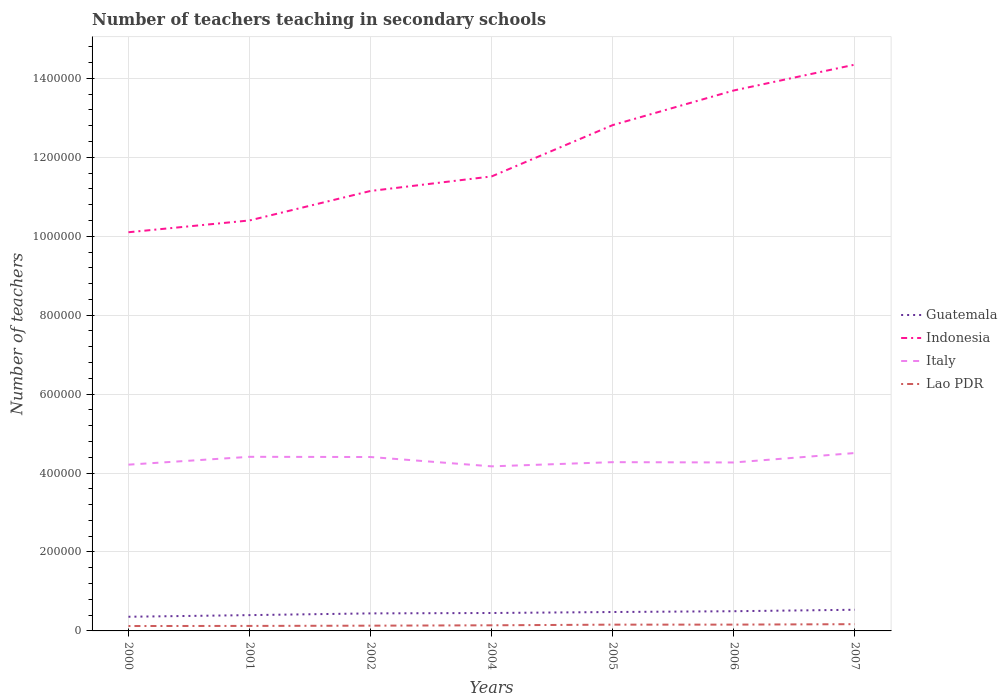How many different coloured lines are there?
Your answer should be compact. 4. Does the line corresponding to Italy intersect with the line corresponding to Indonesia?
Provide a short and direct response. No. Across all years, what is the maximum number of teachers teaching in secondary schools in Indonesia?
Your answer should be very brief. 1.01e+06. In which year was the number of teachers teaching in secondary schools in Italy maximum?
Keep it short and to the point. 2004. What is the total number of teachers teaching in secondary schools in Guatemala in the graph?
Your answer should be very brief. -2504. What is the difference between the highest and the second highest number of teachers teaching in secondary schools in Italy?
Your answer should be compact. 3.37e+04. What is the difference between the highest and the lowest number of teachers teaching in secondary schools in Italy?
Your answer should be very brief. 3. Does the graph contain any zero values?
Provide a succinct answer. No. How are the legend labels stacked?
Provide a short and direct response. Vertical. What is the title of the graph?
Offer a terse response. Number of teachers teaching in secondary schools. Does "Sint Maarten (Dutch part)" appear as one of the legend labels in the graph?
Your answer should be compact. No. What is the label or title of the X-axis?
Offer a very short reply. Years. What is the label or title of the Y-axis?
Keep it short and to the point. Number of teachers. What is the Number of teachers of Guatemala in 2000?
Your answer should be compact. 3.59e+04. What is the Number of teachers in Indonesia in 2000?
Give a very brief answer. 1.01e+06. What is the Number of teachers of Italy in 2000?
Make the answer very short. 4.21e+05. What is the Number of teachers of Lao PDR in 2000?
Keep it short and to the point. 1.24e+04. What is the Number of teachers of Guatemala in 2001?
Keep it short and to the point. 4.00e+04. What is the Number of teachers of Indonesia in 2001?
Ensure brevity in your answer.  1.04e+06. What is the Number of teachers in Italy in 2001?
Offer a very short reply. 4.41e+05. What is the Number of teachers of Lao PDR in 2001?
Give a very brief answer. 1.27e+04. What is the Number of teachers in Guatemala in 2002?
Provide a short and direct response. 4.44e+04. What is the Number of teachers of Indonesia in 2002?
Ensure brevity in your answer.  1.11e+06. What is the Number of teachers of Italy in 2002?
Offer a terse response. 4.41e+05. What is the Number of teachers in Lao PDR in 2002?
Ensure brevity in your answer.  1.33e+04. What is the Number of teachers of Guatemala in 2004?
Make the answer very short. 4.54e+04. What is the Number of teachers of Indonesia in 2004?
Offer a terse response. 1.15e+06. What is the Number of teachers of Italy in 2004?
Make the answer very short. 4.17e+05. What is the Number of teachers of Lao PDR in 2004?
Provide a succinct answer. 1.43e+04. What is the Number of teachers in Guatemala in 2005?
Provide a short and direct response. 4.79e+04. What is the Number of teachers in Indonesia in 2005?
Provide a succinct answer. 1.28e+06. What is the Number of teachers in Italy in 2005?
Provide a succinct answer. 4.28e+05. What is the Number of teachers of Lao PDR in 2005?
Offer a terse response. 1.59e+04. What is the Number of teachers in Guatemala in 2006?
Your response must be concise. 4.99e+04. What is the Number of teachers of Indonesia in 2006?
Provide a short and direct response. 1.37e+06. What is the Number of teachers in Italy in 2006?
Provide a short and direct response. 4.27e+05. What is the Number of teachers in Lao PDR in 2006?
Your response must be concise. 1.60e+04. What is the Number of teachers of Guatemala in 2007?
Your response must be concise. 5.36e+04. What is the Number of teachers of Indonesia in 2007?
Your answer should be compact. 1.43e+06. What is the Number of teachers in Italy in 2007?
Provide a short and direct response. 4.51e+05. What is the Number of teachers of Lao PDR in 2007?
Provide a succinct answer. 1.71e+04. Across all years, what is the maximum Number of teachers in Guatemala?
Your answer should be very brief. 5.36e+04. Across all years, what is the maximum Number of teachers in Indonesia?
Provide a short and direct response. 1.43e+06. Across all years, what is the maximum Number of teachers in Italy?
Give a very brief answer. 4.51e+05. Across all years, what is the maximum Number of teachers in Lao PDR?
Your answer should be very brief. 1.71e+04. Across all years, what is the minimum Number of teachers of Guatemala?
Ensure brevity in your answer.  3.59e+04. Across all years, what is the minimum Number of teachers in Indonesia?
Your answer should be very brief. 1.01e+06. Across all years, what is the minimum Number of teachers in Italy?
Your answer should be compact. 4.17e+05. Across all years, what is the minimum Number of teachers of Lao PDR?
Your answer should be compact. 1.24e+04. What is the total Number of teachers in Guatemala in the graph?
Offer a very short reply. 3.17e+05. What is the total Number of teachers in Indonesia in the graph?
Offer a terse response. 8.40e+06. What is the total Number of teachers in Italy in the graph?
Provide a succinct answer. 3.03e+06. What is the total Number of teachers in Lao PDR in the graph?
Keep it short and to the point. 1.02e+05. What is the difference between the Number of teachers in Guatemala in 2000 and that in 2001?
Offer a very short reply. -4119. What is the difference between the Number of teachers of Indonesia in 2000 and that in 2001?
Your answer should be compact. -2.99e+04. What is the difference between the Number of teachers in Italy in 2000 and that in 2001?
Your answer should be compact. -1.99e+04. What is the difference between the Number of teachers in Lao PDR in 2000 and that in 2001?
Your answer should be compact. -284. What is the difference between the Number of teachers in Guatemala in 2000 and that in 2002?
Your response must be concise. -8525. What is the difference between the Number of teachers in Indonesia in 2000 and that in 2002?
Give a very brief answer. -1.05e+05. What is the difference between the Number of teachers of Italy in 2000 and that in 2002?
Provide a succinct answer. -1.94e+04. What is the difference between the Number of teachers of Lao PDR in 2000 and that in 2002?
Provide a succinct answer. -894. What is the difference between the Number of teachers of Guatemala in 2000 and that in 2004?
Keep it short and to the point. -9490. What is the difference between the Number of teachers in Indonesia in 2000 and that in 2004?
Ensure brevity in your answer.  -1.41e+05. What is the difference between the Number of teachers in Italy in 2000 and that in 2004?
Offer a terse response. 4274. What is the difference between the Number of teachers in Lao PDR in 2000 and that in 2004?
Your response must be concise. -1855. What is the difference between the Number of teachers of Guatemala in 2000 and that in 2005?
Your answer should be very brief. -1.20e+04. What is the difference between the Number of teachers of Indonesia in 2000 and that in 2005?
Your answer should be compact. -2.71e+05. What is the difference between the Number of teachers of Italy in 2000 and that in 2005?
Your answer should be compact. -6349. What is the difference between the Number of teachers in Lao PDR in 2000 and that in 2005?
Provide a succinct answer. -3489. What is the difference between the Number of teachers of Guatemala in 2000 and that in 2006?
Offer a terse response. -1.40e+04. What is the difference between the Number of teachers in Indonesia in 2000 and that in 2006?
Ensure brevity in your answer.  -3.59e+05. What is the difference between the Number of teachers of Italy in 2000 and that in 2006?
Provide a succinct answer. -5525. What is the difference between the Number of teachers of Lao PDR in 2000 and that in 2006?
Ensure brevity in your answer.  -3585. What is the difference between the Number of teachers in Guatemala in 2000 and that in 2007?
Ensure brevity in your answer.  -1.77e+04. What is the difference between the Number of teachers of Indonesia in 2000 and that in 2007?
Ensure brevity in your answer.  -4.25e+05. What is the difference between the Number of teachers in Italy in 2000 and that in 2007?
Keep it short and to the point. -2.95e+04. What is the difference between the Number of teachers of Lao PDR in 2000 and that in 2007?
Your answer should be compact. -4708. What is the difference between the Number of teachers of Guatemala in 2001 and that in 2002?
Offer a terse response. -4406. What is the difference between the Number of teachers of Indonesia in 2001 and that in 2002?
Provide a succinct answer. -7.47e+04. What is the difference between the Number of teachers in Italy in 2001 and that in 2002?
Offer a terse response. 501. What is the difference between the Number of teachers of Lao PDR in 2001 and that in 2002?
Offer a terse response. -610. What is the difference between the Number of teachers in Guatemala in 2001 and that in 2004?
Keep it short and to the point. -5371. What is the difference between the Number of teachers of Indonesia in 2001 and that in 2004?
Provide a short and direct response. -1.12e+05. What is the difference between the Number of teachers in Italy in 2001 and that in 2004?
Your response must be concise. 2.41e+04. What is the difference between the Number of teachers in Lao PDR in 2001 and that in 2004?
Provide a short and direct response. -1571. What is the difference between the Number of teachers in Guatemala in 2001 and that in 2005?
Your response must be concise. -7875. What is the difference between the Number of teachers of Indonesia in 2001 and that in 2005?
Your answer should be very brief. -2.42e+05. What is the difference between the Number of teachers of Italy in 2001 and that in 2005?
Your answer should be very brief. 1.35e+04. What is the difference between the Number of teachers in Lao PDR in 2001 and that in 2005?
Provide a succinct answer. -3205. What is the difference between the Number of teachers in Guatemala in 2001 and that in 2006?
Provide a short and direct response. -9906. What is the difference between the Number of teachers of Indonesia in 2001 and that in 2006?
Your response must be concise. -3.29e+05. What is the difference between the Number of teachers of Italy in 2001 and that in 2006?
Your answer should be compact. 1.43e+04. What is the difference between the Number of teachers in Lao PDR in 2001 and that in 2006?
Offer a very short reply. -3301. What is the difference between the Number of teachers in Guatemala in 2001 and that in 2007?
Offer a very short reply. -1.36e+04. What is the difference between the Number of teachers of Indonesia in 2001 and that in 2007?
Provide a succinct answer. -3.95e+05. What is the difference between the Number of teachers of Italy in 2001 and that in 2007?
Your answer should be very brief. -9589. What is the difference between the Number of teachers in Lao PDR in 2001 and that in 2007?
Keep it short and to the point. -4424. What is the difference between the Number of teachers of Guatemala in 2002 and that in 2004?
Your answer should be compact. -965. What is the difference between the Number of teachers of Indonesia in 2002 and that in 2004?
Your response must be concise. -3.68e+04. What is the difference between the Number of teachers of Italy in 2002 and that in 2004?
Your response must be concise. 2.36e+04. What is the difference between the Number of teachers of Lao PDR in 2002 and that in 2004?
Offer a terse response. -961. What is the difference between the Number of teachers in Guatemala in 2002 and that in 2005?
Offer a very short reply. -3469. What is the difference between the Number of teachers of Indonesia in 2002 and that in 2005?
Give a very brief answer. -1.67e+05. What is the difference between the Number of teachers of Italy in 2002 and that in 2005?
Your answer should be compact. 1.30e+04. What is the difference between the Number of teachers of Lao PDR in 2002 and that in 2005?
Give a very brief answer. -2595. What is the difference between the Number of teachers of Guatemala in 2002 and that in 2006?
Your response must be concise. -5500. What is the difference between the Number of teachers of Indonesia in 2002 and that in 2006?
Provide a succinct answer. -2.55e+05. What is the difference between the Number of teachers of Italy in 2002 and that in 2006?
Provide a short and direct response. 1.38e+04. What is the difference between the Number of teachers of Lao PDR in 2002 and that in 2006?
Your answer should be very brief. -2691. What is the difference between the Number of teachers in Guatemala in 2002 and that in 2007?
Your answer should be very brief. -9195. What is the difference between the Number of teachers in Indonesia in 2002 and that in 2007?
Keep it short and to the point. -3.20e+05. What is the difference between the Number of teachers of Italy in 2002 and that in 2007?
Offer a terse response. -1.01e+04. What is the difference between the Number of teachers of Lao PDR in 2002 and that in 2007?
Make the answer very short. -3814. What is the difference between the Number of teachers of Guatemala in 2004 and that in 2005?
Your response must be concise. -2504. What is the difference between the Number of teachers in Indonesia in 2004 and that in 2005?
Offer a very short reply. -1.30e+05. What is the difference between the Number of teachers in Italy in 2004 and that in 2005?
Give a very brief answer. -1.06e+04. What is the difference between the Number of teachers of Lao PDR in 2004 and that in 2005?
Your answer should be compact. -1634. What is the difference between the Number of teachers in Guatemala in 2004 and that in 2006?
Give a very brief answer. -4535. What is the difference between the Number of teachers in Indonesia in 2004 and that in 2006?
Offer a very short reply. -2.18e+05. What is the difference between the Number of teachers of Italy in 2004 and that in 2006?
Offer a very short reply. -9799. What is the difference between the Number of teachers of Lao PDR in 2004 and that in 2006?
Provide a short and direct response. -1730. What is the difference between the Number of teachers in Guatemala in 2004 and that in 2007?
Give a very brief answer. -8230. What is the difference between the Number of teachers of Indonesia in 2004 and that in 2007?
Ensure brevity in your answer.  -2.83e+05. What is the difference between the Number of teachers in Italy in 2004 and that in 2007?
Your answer should be compact. -3.37e+04. What is the difference between the Number of teachers of Lao PDR in 2004 and that in 2007?
Provide a short and direct response. -2853. What is the difference between the Number of teachers of Guatemala in 2005 and that in 2006?
Your answer should be very brief. -2031. What is the difference between the Number of teachers in Indonesia in 2005 and that in 2006?
Make the answer very short. -8.77e+04. What is the difference between the Number of teachers of Italy in 2005 and that in 2006?
Provide a succinct answer. 824. What is the difference between the Number of teachers in Lao PDR in 2005 and that in 2006?
Provide a short and direct response. -96. What is the difference between the Number of teachers in Guatemala in 2005 and that in 2007?
Give a very brief answer. -5726. What is the difference between the Number of teachers of Indonesia in 2005 and that in 2007?
Keep it short and to the point. -1.53e+05. What is the difference between the Number of teachers of Italy in 2005 and that in 2007?
Give a very brief answer. -2.31e+04. What is the difference between the Number of teachers of Lao PDR in 2005 and that in 2007?
Give a very brief answer. -1219. What is the difference between the Number of teachers in Guatemala in 2006 and that in 2007?
Keep it short and to the point. -3695. What is the difference between the Number of teachers in Indonesia in 2006 and that in 2007?
Provide a short and direct response. -6.54e+04. What is the difference between the Number of teachers of Italy in 2006 and that in 2007?
Keep it short and to the point. -2.39e+04. What is the difference between the Number of teachers of Lao PDR in 2006 and that in 2007?
Make the answer very short. -1123. What is the difference between the Number of teachers of Guatemala in 2000 and the Number of teachers of Indonesia in 2001?
Give a very brief answer. -1.00e+06. What is the difference between the Number of teachers of Guatemala in 2000 and the Number of teachers of Italy in 2001?
Make the answer very short. -4.05e+05. What is the difference between the Number of teachers in Guatemala in 2000 and the Number of teachers in Lao PDR in 2001?
Offer a very short reply. 2.32e+04. What is the difference between the Number of teachers of Indonesia in 2000 and the Number of teachers of Italy in 2001?
Ensure brevity in your answer.  5.69e+05. What is the difference between the Number of teachers of Indonesia in 2000 and the Number of teachers of Lao PDR in 2001?
Your response must be concise. 9.98e+05. What is the difference between the Number of teachers in Italy in 2000 and the Number of teachers in Lao PDR in 2001?
Give a very brief answer. 4.09e+05. What is the difference between the Number of teachers of Guatemala in 2000 and the Number of teachers of Indonesia in 2002?
Your answer should be compact. -1.08e+06. What is the difference between the Number of teachers of Guatemala in 2000 and the Number of teachers of Italy in 2002?
Ensure brevity in your answer.  -4.05e+05. What is the difference between the Number of teachers of Guatemala in 2000 and the Number of teachers of Lao PDR in 2002?
Offer a very short reply. 2.26e+04. What is the difference between the Number of teachers of Indonesia in 2000 and the Number of teachers of Italy in 2002?
Provide a short and direct response. 5.70e+05. What is the difference between the Number of teachers in Indonesia in 2000 and the Number of teachers in Lao PDR in 2002?
Offer a very short reply. 9.97e+05. What is the difference between the Number of teachers of Italy in 2000 and the Number of teachers of Lao PDR in 2002?
Provide a succinct answer. 4.08e+05. What is the difference between the Number of teachers in Guatemala in 2000 and the Number of teachers in Indonesia in 2004?
Your response must be concise. -1.12e+06. What is the difference between the Number of teachers in Guatemala in 2000 and the Number of teachers in Italy in 2004?
Your answer should be very brief. -3.81e+05. What is the difference between the Number of teachers of Guatemala in 2000 and the Number of teachers of Lao PDR in 2004?
Provide a short and direct response. 2.17e+04. What is the difference between the Number of teachers in Indonesia in 2000 and the Number of teachers in Italy in 2004?
Give a very brief answer. 5.93e+05. What is the difference between the Number of teachers of Indonesia in 2000 and the Number of teachers of Lao PDR in 2004?
Your answer should be compact. 9.96e+05. What is the difference between the Number of teachers of Italy in 2000 and the Number of teachers of Lao PDR in 2004?
Give a very brief answer. 4.07e+05. What is the difference between the Number of teachers in Guatemala in 2000 and the Number of teachers in Indonesia in 2005?
Your answer should be compact. -1.25e+06. What is the difference between the Number of teachers of Guatemala in 2000 and the Number of teachers of Italy in 2005?
Ensure brevity in your answer.  -3.92e+05. What is the difference between the Number of teachers of Guatemala in 2000 and the Number of teachers of Lao PDR in 2005?
Give a very brief answer. 2.00e+04. What is the difference between the Number of teachers of Indonesia in 2000 and the Number of teachers of Italy in 2005?
Your answer should be compact. 5.83e+05. What is the difference between the Number of teachers in Indonesia in 2000 and the Number of teachers in Lao PDR in 2005?
Offer a terse response. 9.94e+05. What is the difference between the Number of teachers of Italy in 2000 and the Number of teachers of Lao PDR in 2005?
Provide a succinct answer. 4.05e+05. What is the difference between the Number of teachers in Guatemala in 2000 and the Number of teachers in Indonesia in 2006?
Provide a succinct answer. -1.33e+06. What is the difference between the Number of teachers of Guatemala in 2000 and the Number of teachers of Italy in 2006?
Provide a succinct answer. -3.91e+05. What is the difference between the Number of teachers in Guatemala in 2000 and the Number of teachers in Lao PDR in 2006?
Keep it short and to the point. 1.99e+04. What is the difference between the Number of teachers in Indonesia in 2000 and the Number of teachers in Italy in 2006?
Provide a short and direct response. 5.83e+05. What is the difference between the Number of teachers in Indonesia in 2000 and the Number of teachers in Lao PDR in 2006?
Give a very brief answer. 9.94e+05. What is the difference between the Number of teachers of Italy in 2000 and the Number of teachers of Lao PDR in 2006?
Your answer should be compact. 4.05e+05. What is the difference between the Number of teachers of Guatemala in 2000 and the Number of teachers of Indonesia in 2007?
Your answer should be compact. -1.40e+06. What is the difference between the Number of teachers in Guatemala in 2000 and the Number of teachers in Italy in 2007?
Offer a very short reply. -4.15e+05. What is the difference between the Number of teachers of Guatemala in 2000 and the Number of teachers of Lao PDR in 2007?
Provide a succinct answer. 1.88e+04. What is the difference between the Number of teachers in Indonesia in 2000 and the Number of teachers in Italy in 2007?
Keep it short and to the point. 5.59e+05. What is the difference between the Number of teachers in Indonesia in 2000 and the Number of teachers in Lao PDR in 2007?
Offer a terse response. 9.93e+05. What is the difference between the Number of teachers of Italy in 2000 and the Number of teachers of Lao PDR in 2007?
Offer a very short reply. 4.04e+05. What is the difference between the Number of teachers of Guatemala in 2001 and the Number of teachers of Indonesia in 2002?
Ensure brevity in your answer.  -1.07e+06. What is the difference between the Number of teachers of Guatemala in 2001 and the Number of teachers of Italy in 2002?
Your answer should be very brief. -4.01e+05. What is the difference between the Number of teachers in Guatemala in 2001 and the Number of teachers in Lao PDR in 2002?
Your answer should be compact. 2.67e+04. What is the difference between the Number of teachers of Indonesia in 2001 and the Number of teachers of Italy in 2002?
Offer a terse response. 5.99e+05. What is the difference between the Number of teachers in Indonesia in 2001 and the Number of teachers in Lao PDR in 2002?
Provide a succinct answer. 1.03e+06. What is the difference between the Number of teachers in Italy in 2001 and the Number of teachers in Lao PDR in 2002?
Provide a succinct answer. 4.28e+05. What is the difference between the Number of teachers in Guatemala in 2001 and the Number of teachers in Indonesia in 2004?
Offer a terse response. -1.11e+06. What is the difference between the Number of teachers in Guatemala in 2001 and the Number of teachers in Italy in 2004?
Provide a succinct answer. -3.77e+05. What is the difference between the Number of teachers of Guatemala in 2001 and the Number of teachers of Lao PDR in 2004?
Provide a succinct answer. 2.58e+04. What is the difference between the Number of teachers in Indonesia in 2001 and the Number of teachers in Italy in 2004?
Keep it short and to the point. 6.23e+05. What is the difference between the Number of teachers of Indonesia in 2001 and the Number of teachers of Lao PDR in 2004?
Keep it short and to the point. 1.03e+06. What is the difference between the Number of teachers in Italy in 2001 and the Number of teachers in Lao PDR in 2004?
Give a very brief answer. 4.27e+05. What is the difference between the Number of teachers in Guatemala in 2001 and the Number of teachers in Indonesia in 2005?
Your answer should be very brief. -1.24e+06. What is the difference between the Number of teachers of Guatemala in 2001 and the Number of teachers of Italy in 2005?
Provide a succinct answer. -3.88e+05. What is the difference between the Number of teachers of Guatemala in 2001 and the Number of teachers of Lao PDR in 2005?
Your response must be concise. 2.41e+04. What is the difference between the Number of teachers in Indonesia in 2001 and the Number of teachers in Italy in 2005?
Ensure brevity in your answer.  6.12e+05. What is the difference between the Number of teachers in Indonesia in 2001 and the Number of teachers in Lao PDR in 2005?
Give a very brief answer. 1.02e+06. What is the difference between the Number of teachers of Italy in 2001 and the Number of teachers of Lao PDR in 2005?
Your answer should be very brief. 4.25e+05. What is the difference between the Number of teachers of Guatemala in 2001 and the Number of teachers of Indonesia in 2006?
Your answer should be compact. -1.33e+06. What is the difference between the Number of teachers in Guatemala in 2001 and the Number of teachers in Italy in 2006?
Give a very brief answer. -3.87e+05. What is the difference between the Number of teachers of Guatemala in 2001 and the Number of teachers of Lao PDR in 2006?
Offer a terse response. 2.40e+04. What is the difference between the Number of teachers of Indonesia in 2001 and the Number of teachers of Italy in 2006?
Give a very brief answer. 6.13e+05. What is the difference between the Number of teachers in Indonesia in 2001 and the Number of teachers in Lao PDR in 2006?
Keep it short and to the point. 1.02e+06. What is the difference between the Number of teachers in Italy in 2001 and the Number of teachers in Lao PDR in 2006?
Give a very brief answer. 4.25e+05. What is the difference between the Number of teachers in Guatemala in 2001 and the Number of teachers in Indonesia in 2007?
Give a very brief answer. -1.39e+06. What is the difference between the Number of teachers of Guatemala in 2001 and the Number of teachers of Italy in 2007?
Ensure brevity in your answer.  -4.11e+05. What is the difference between the Number of teachers in Guatemala in 2001 and the Number of teachers in Lao PDR in 2007?
Give a very brief answer. 2.29e+04. What is the difference between the Number of teachers of Indonesia in 2001 and the Number of teachers of Italy in 2007?
Provide a succinct answer. 5.89e+05. What is the difference between the Number of teachers of Indonesia in 2001 and the Number of teachers of Lao PDR in 2007?
Keep it short and to the point. 1.02e+06. What is the difference between the Number of teachers in Italy in 2001 and the Number of teachers in Lao PDR in 2007?
Your response must be concise. 4.24e+05. What is the difference between the Number of teachers of Guatemala in 2002 and the Number of teachers of Indonesia in 2004?
Give a very brief answer. -1.11e+06. What is the difference between the Number of teachers of Guatemala in 2002 and the Number of teachers of Italy in 2004?
Offer a very short reply. -3.73e+05. What is the difference between the Number of teachers in Guatemala in 2002 and the Number of teachers in Lao PDR in 2004?
Provide a short and direct response. 3.02e+04. What is the difference between the Number of teachers of Indonesia in 2002 and the Number of teachers of Italy in 2004?
Your answer should be compact. 6.98e+05. What is the difference between the Number of teachers in Indonesia in 2002 and the Number of teachers in Lao PDR in 2004?
Your answer should be very brief. 1.10e+06. What is the difference between the Number of teachers in Italy in 2002 and the Number of teachers in Lao PDR in 2004?
Your answer should be compact. 4.26e+05. What is the difference between the Number of teachers of Guatemala in 2002 and the Number of teachers of Indonesia in 2005?
Your answer should be compact. -1.24e+06. What is the difference between the Number of teachers in Guatemala in 2002 and the Number of teachers in Italy in 2005?
Your answer should be very brief. -3.83e+05. What is the difference between the Number of teachers in Guatemala in 2002 and the Number of teachers in Lao PDR in 2005?
Your response must be concise. 2.85e+04. What is the difference between the Number of teachers in Indonesia in 2002 and the Number of teachers in Italy in 2005?
Your response must be concise. 6.87e+05. What is the difference between the Number of teachers in Indonesia in 2002 and the Number of teachers in Lao PDR in 2005?
Offer a terse response. 1.10e+06. What is the difference between the Number of teachers in Italy in 2002 and the Number of teachers in Lao PDR in 2005?
Your answer should be compact. 4.25e+05. What is the difference between the Number of teachers of Guatemala in 2002 and the Number of teachers of Indonesia in 2006?
Your answer should be compact. -1.32e+06. What is the difference between the Number of teachers of Guatemala in 2002 and the Number of teachers of Italy in 2006?
Provide a succinct answer. -3.82e+05. What is the difference between the Number of teachers in Guatemala in 2002 and the Number of teachers in Lao PDR in 2006?
Keep it short and to the point. 2.84e+04. What is the difference between the Number of teachers of Indonesia in 2002 and the Number of teachers of Italy in 2006?
Offer a terse response. 6.88e+05. What is the difference between the Number of teachers of Indonesia in 2002 and the Number of teachers of Lao PDR in 2006?
Your answer should be compact. 1.10e+06. What is the difference between the Number of teachers of Italy in 2002 and the Number of teachers of Lao PDR in 2006?
Provide a short and direct response. 4.25e+05. What is the difference between the Number of teachers of Guatemala in 2002 and the Number of teachers of Indonesia in 2007?
Your response must be concise. -1.39e+06. What is the difference between the Number of teachers of Guatemala in 2002 and the Number of teachers of Italy in 2007?
Provide a short and direct response. -4.06e+05. What is the difference between the Number of teachers in Guatemala in 2002 and the Number of teachers in Lao PDR in 2007?
Give a very brief answer. 2.73e+04. What is the difference between the Number of teachers of Indonesia in 2002 and the Number of teachers of Italy in 2007?
Your answer should be very brief. 6.64e+05. What is the difference between the Number of teachers in Indonesia in 2002 and the Number of teachers in Lao PDR in 2007?
Offer a very short reply. 1.10e+06. What is the difference between the Number of teachers of Italy in 2002 and the Number of teachers of Lao PDR in 2007?
Ensure brevity in your answer.  4.24e+05. What is the difference between the Number of teachers of Guatemala in 2004 and the Number of teachers of Indonesia in 2005?
Make the answer very short. -1.24e+06. What is the difference between the Number of teachers of Guatemala in 2004 and the Number of teachers of Italy in 2005?
Provide a succinct answer. -3.82e+05. What is the difference between the Number of teachers in Guatemala in 2004 and the Number of teachers in Lao PDR in 2005?
Offer a very short reply. 2.95e+04. What is the difference between the Number of teachers in Indonesia in 2004 and the Number of teachers in Italy in 2005?
Keep it short and to the point. 7.24e+05. What is the difference between the Number of teachers in Indonesia in 2004 and the Number of teachers in Lao PDR in 2005?
Your answer should be very brief. 1.14e+06. What is the difference between the Number of teachers of Italy in 2004 and the Number of teachers of Lao PDR in 2005?
Give a very brief answer. 4.01e+05. What is the difference between the Number of teachers in Guatemala in 2004 and the Number of teachers in Indonesia in 2006?
Provide a short and direct response. -1.32e+06. What is the difference between the Number of teachers of Guatemala in 2004 and the Number of teachers of Italy in 2006?
Give a very brief answer. -3.81e+05. What is the difference between the Number of teachers in Guatemala in 2004 and the Number of teachers in Lao PDR in 2006?
Give a very brief answer. 2.94e+04. What is the difference between the Number of teachers of Indonesia in 2004 and the Number of teachers of Italy in 2006?
Provide a succinct answer. 7.25e+05. What is the difference between the Number of teachers of Indonesia in 2004 and the Number of teachers of Lao PDR in 2006?
Offer a terse response. 1.14e+06. What is the difference between the Number of teachers in Italy in 2004 and the Number of teachers in Lao PDR in 2006?
Your answer should be compact. 4.01e+05. What is the difference between the Number of teachers of Guatemala in 2004 and the Number of teachers of Indonesia in 2007?
Keep it short and to the point. -1.39e+06. What is the difference between the Number of teachers of Guatemala in 2004 and the Number of teachers of Italy in 2007?
Your response must be concise. -4.05e+05. What is the difference between the Number of teachers in Guatemala in 2004 and the Number of teachers in Lao PDR in 2007?
Keep it short and to the point. 2.83e+04. What is the difference between the Number of teachers in Indonesia in 2004 and the Number of teachers in Italy in 2007?
Your response must be concise. 7.01e+05. What is the difference between the Number of teachers of Indonesia in 2004 and the Number of teachers of Lao PDR in 2007?
Your answer should be compact. 1.13e+06. What is the difference between the Number of teachers in Italy in 2004 and the Number of teachers in Lao PDR in 2007?
Your answer should be very brief. 4.00e+05. What is the difference between the Number of teachers of Guatemala in 2005 and the Number of teachers of Indonesia in 2006?
Keep it short and to the point. -1.32e+06. What is the difference between the Number of teachers of Guatemala in 2005 and the Number of teachers of Italy in 2006?
Your answer should be compact. -3.79e+05. What is the difference between the Number of teachers in Guatemala in 2005 and the Number of teachers in Lao PDR in 2006?
Offer a terse response. 3.19e+04. What is the difference between the Number of teachers of Indonesia in 2005 and the Number of teachers of Italy in 2006?
Your answer should be compact. 8.55e+05. What is the difference between the Number of teachers of Indonesia in 2005 and the Number of teachers of Lao PDR in 2006?
Provide a succinct answer. 1.27e+06. What is the difference between the Number of teachers in Italy in 2005 and the Number of teachers in Lao PDR in 2006?
Give a very brief answer. 4.12e+05. What is the difference between the Number of teachers of Guatemala in 2005 and the Number of teachers of Indonesia in 2007?
Offer a terse response. -1.39e+06. What is the difference between the Number of teachers in Guatemala in 2005 and the Number of teachers in Italy in 2007?
Provide a short and direct response. -4.03e+05. What is the difference between the Number of teachers of Guatemala in 2005 and the Number of teachers of Lao PDR in 2007?
Your answer should be very brief. 3.08e+04. What is the difference between the Number of teachers in Indonesia in 2005 and the Number of teachers in Italy in 2007?
Give a very brief answer. 8.31e+05. What is the difference between the Number of teachers of Indonesia in 2005 and the Number of teachers of Lao PDR in 2007?
Your response must be concise. 1.26e+06. What is the difference between the Number of teachers in Italy in 2005 and the Number of teachers in Lao PDR in 2007?
Your answer should be compact. 4.11e+05. What is the difference between the Number of teachers in Guatemala in 2006 and the Number of teachers in Indonesia in 2007?
Provide a succinct answer. -1.38e+06. What is the difference between the Number of teachers of Guatemala in 2006 and the Number of teachers of Italy in 2007?
Provide a short and direct response. -4.01e+05. What is the difference between the Number of teachers of Guatemala in 2006 and the Number of teachers of Lao PDR in 2007?
Give a very brief answer. 3.28e+04. What is the difference between the Number of teachers of Indonesia in 2006 and the Number of teachers of Italy in 2007?
Offer a very short reply. 9.19e+05. What is the difference between the Number of teachers in Indonesia in 2006 and the Number of teachers in Lao PDR in 2007?
Your answer should be very brief. 1.35e+06. What is the difference between the Number of teachers in Italy in 2006 and the Number of teachers in Lao PDR in 2007?
Ensure brevity in your answer.  4.10e+05. What is the average Number of teachers of Guatemala per year?
Provide a succinct answer. 4.53e+04. What is the average Number of teachers in Indonesia per year?
Your answer should be very brief. 1.20e+06. What is the average Number of teachers of Italy per year?
Provide a succinct answer. 4.32e+05. What is the average Number of teachers in Lao PDR per year?
Make the answer very short. 1.45e+04. In the year 2000, what is the difference between the Number of teachers of Guatemala and Number of teachers of Indonesia?
Ensure brevity in your answer.  -9.74e+05. In the year 2000, what is the difference between the Number of teachers in Guatemala and Number of teachers in Italy?
Keep it short and to the point. -3.85e+05. In the year 2000, what is the difference between the Number of teachers of Guatemala and Number of teachers of Lao PDR?
Provide a short and direct response. 2.35e+04. In the year 2000, what is the difference between the Number of teachers of Indonesia and Number of teachers of Italy?
Make the answer very short. 5.89e+05. In the year 2000, what is the difference between the Number of teachers of Indonesia and Number of teachers of Lao PDR?
Give a very brief answer. 9.98e+05. In the year 2000, what is the difference between the Number of teachers of Italy and Number of teachers of Lao PDR?
Make the answer very short. 4.09e+05. In the year 2001, what is the difference between the Number of teachers of Guatemala and Number of teachers of Indonesia?
Give a very brief answer. -1.00e+06. In the year 2001, what is the difference between the Number of teachers of Guatemala and Number of teachers of Italy?
Your answer should be compact. -4.01e+05. In the year 2001, what is the difference between the Number of teachers in Guatemala and Number of teachers in Lao PDR?
Offer a terse response. 2.73e+04. In the year 2001, what is the difference between the Number of teachers in Indonesia and Number of teachers in Italy?
Provide a short and direct response. 5.99e+05. In the year 2001, what is the difference between the Number of teachers in Indonesia and Number of teachers in Lao PDR?
Give a very brief answer. 1.03e+06. In the year 2001, what is the difference between the Number of teachers in Italy and Number of teachers in Lao PDR?
Your response must be concise. 4.28e+05. In the year 2002, what is the difference between the Number of teachers of Guatemala and Number of teachers of Indonesia?
Keep it short and to the point. -1.07e+06. In the year 2002, what is the difference between the Number of teachers of Guatemala and Number of teachers of Italy?
Make the answer very short. -3.96e+05. In the year 2002, what is the difference between the Number of teachers of Guatemala and Number of teachers of Lao PDR?
Ensure brevity in your answer.  3.11e+04. In the year 2002, what is the difference between the Number of teachers in Indonesia and Number of teachers in Italy?
Offer a very short reply. 6.74e+05. In the year 2002, what is the difference between the Number of teachers in Indonesia and Number of teachers in Lao PDR?
Ensure brevity in your answer.  1.10e+06. In the year 2002, what is the difference between the Number of teachers of Italy and Number of teachers of Lao PDR?
Make the answer very short. 4.27e+05. In the year 2004, what is the difference between the Number of teachers of Guatemala and Number of teachers of Indonesia?
Give a very brief answer. -1.11e+06. In the year 2004, what is the difference between the Number of teachers in Guatemala and Number of teachers in Italy?
Make the answer very short. -3.72e+05. In the year 2004, what is the difference between the Number of teachers in Guatemala and Number of teachers in Lao PDR?
Make the answer very short. 3.11e+04. In the year 2004, what is the difference between the Number of teachers of Indonesia and Number of teachers of Italy?
Give a very brief answer. 7.35e+05. In the year 2004, what is the difference between the Number of teachers of Indonesia and Number of teachers of Lao PDR?
Offer a very short reply. 1.14e+06. In the year 2004, what is the difference between the Number of teachers of Italy and Number of teachers of Lao PDR?
Offer a very short reply. 4.03e+05. In the year 2005, what is the difference between the Number of teachers of Guatemala and Number of teachers of Indonesia?
Ensure brevity in your answer.  -1.23e+06. In the year 2005, what is the difference between the Number of teachers in Guatemala and Number of teachers in Italy?
Your answer should be very brief. -3.80e+05. In the year 2005, what is the difference between the Number of teachers of Guatemala and Number of teachers of Lao PDR?
Your answer should be very brief. 3.20e+04. In the year 2005, what is the difference between the Number of teachers of Indonesia and Number of teachers of Italy?
Your answer should be very brief. 8.54e+05. In the year 2005, what is the difference between the Number of teachers in Indonesia and Number of teachers in Lao PDR?
Keep it short and to the point. 1.27e+06. In the year 2005, what is the difference between the Number of teachers in Italy and Number of teachers in Lao PDR?
Your answer should be very brief. 4.12e+05. In the year 2006, what is the difference between the Number of teachers in Guatemala and Number of teachers in Indonesia?
Provide a succinct answer. -1.32e+06. In the year 2006, what is the difference between the Number of teachers in Guatemala and Number of teachers in Italy?
Ensure brevity in your answer.  -3.77e+05. In the year 2006, what is the difference between the Number of teachers in Guatemala and Number of teachers in Lao PDR?
Make the answer very short. 3.39e+04. In the year 2006, what is the difference between the Number of teachers in Indonesia and Number of teachers in Italy?
Offer a very short reply. 9.43e+05. In the year 2006, what is the difference between the Number of teachers of Indonesia and Number of teachers of Lao PDR?
Give a very brief answer. 1.35e+06. In the year 2006, what is the difference between the Number of teachers of Italy and Number of teachers of Lao PDR?
Provide a succinct answer. 4.11e+05. In the year 2007, what is the difference between the Number of teachers in Guatemala and Number of teachers in Indonesia?
Offer a terse response. -1.38e+06. In the year 2007, what is the difference between the Number of teachers of Guatemala and Number of teachers of Italy?
Offer a very short reply. -3.97e+05. In the year 2007, what is the difference between the Number of teachers in Guatemala and Number of teachers in Lao PDR?
Provide a short and direct response. 3.65e+04. In the year 2007, what is the difference between the Number of teachers of Indonesia and Number of teachers of Italy?
Your answer should be very brief. 9.84e+05. In the year 2007, what is the difference between the Number of teachers in Indonesia and Number of teachers in Lao PDR?
Make the answer very short. 1.42e+06. In the year 2007, what is the difference between the Number of teachers of Italy and Number of teachers of Lao PDR?
Your answer should be compact. 4.34e+05. What is the ratio of the Number of teachers in Guatemala in 2000 to that in 2001?
Offer a terse response. 0.9. What is the ratio of the Number of teachers in Indonesia in 2000 to that in 2001?
Ensure brevity in your answer.  0.97. What is the ratio of the Number of teachers of Italy in 2000 to that in 2001?
Keep it short and to the point. 0.95. What is the ratio of the Number of teachers in Lao PDR in 2000 to that in 2001?
Your answer should be compact. 0.98. What is the ratio of the Number of teachers of Guatemala in 2000 to that in 2002?
Your answer should be compact. 0.81. What is the ratio of the Number of teachers in Indonesia in 2000 to that in 2002?
Provide a succinct answer. 0.91. What is the ratio of the Number of teachers of Italy in 2000 to that in 2002?
Your response must be concise. 0.96. What is the ratio of the Number of teachers in Lao PDR in 2000 to that in 2002?
Keep it short and to the point. 0.93. What is the ratio of the Number of teachers of Guatemala in 2000 to that in 2004?
Keep it short and to the point. 0.79. What is the ratio of the Number of teachers of Indonesia in 2000 to that in 2004?
Give a very brief answer. 0.88. What is the ratio of the Number of teachers in Italy in 2000 to that in 2004?
Ensure brevity in your answer.  1.01. What is the ratio of the Number of teachers in Lao PDR in 2000 to that in 2004?
Keep it short and to the point. 0.87. What is the ratio of the Number of teachers in Guatemala in 2000 to that in 2005?
Offer a very short reply. 0.75. What is the ratio of the Number of teachers of Indonesia in 2000 to that in 2005?
Your response must be concise. 0.79. What is the ratio of the Number of teachers in Italy in 2000 to that in 2005?
Provide a succinct answer. 0.99. What is the ratio of the Number of teachers of Lao PDR in 2000 to that in 2005?
Provide a succinct answer. 0.78. What is the ratio of the Number of teachers in Guatemala in 2000 to that in 2006?
Ensure brevity in your answer.  0.72. What is the ratio of the Number of teachers of Indonesia in 2000 to that in 2006?
Offer a very short reply. 0.74. What is the ratio of the Number of teachers in Italy in 2000 to that in 2006?
Keep it short and to the point. 0.99. What is the ratio of the Number of teachers of Lao PDR in 2000 to that in 2006?
Offer a very short reply. 0.78. What is the ratio of the Number of teachers in Guatemala in 2000 to that in 2007?
Keep it short and to the point. 0.67. What is the ratio of the Number of teachers in Indonesia in 2000 to that in 2007?
Your response must be concise. 0.7. What is the ratio of the Number of teachers in Italy in 2000 to that in 2007?
Your answer should be very brief. 0.93. What is the ratio of the Number of teachers of Lao PDR in 2000 to that in 2007?
Make the answer very short. 0.72. What is the ratio of the Number of teachers in Guatemala in 2001 to that in 2002?
Offer a terse response. 0.9. What is the ratio of the Number of teachers in Indonesia in 2001 to that in 2002?
Provide a short and direct response. 0.93. What is the ratio of the Number of teachers of Italy in 2001 to that in 2002?
Make the answer very short. 1. What is the ratio of the Number of teachers in Lao PDR in 2001 to that in 2002?
Give a very brief answer. 0.95. What is the ratio of the Number of teachers of Guatemala in 2001 to that in 2004?
Your response must be concise. 0.88. What is the ratio of the Number of teachers in Indonesia in 2001 to that in 2004?
Give a very brief answer. 0.9. What is the ratio of the Number of teachers of Italy in 2001 to that in 2004?
Offer a very short reply. 1.06. What is the ratio of the Number of teachers in Lao PDR in 2001 to that in 2004?
Provide a short and direct response. 0.89. What is the ratio of the Number of teachers of Guatemala in 2001 to that in 2005?
Your answer should be very brief. 0.84. What is the ratio of the Number of teachers of Indonesia in 2001 to that in 2005?
Make the answer very short. 0.81. What is the ratio of the Number of teachers in Italy in 2001 to that in 2005?
Provide a short and direct response. 1.03. What is the ratio of the Number of teachers of Lao PDR in 2001 to that in 2005?
Offer a terse response. 0.8. What is the ratio of the Number of teachers in Guatemala in 2001 to that in 2006?
Offer a very short reply. 0.8. What is the ratio of the Number of teachers of Indonesia in 2001 to that in 2006?
Your answer should be compact. 0.76. What is the ratio of the Number of teachers in Italy in 2001 to that in 2006?
Provide a short and direct response. 1.03. What is the ratio of the Number of teachers in Lao PDR in 2001 to that in 2006?
Provide a short and direct response. 0.79. What is the ratio of the Number of teachers of Guatemala in 2001 to that in 2007?
Give a very brief answer. 0.75. What is the ratio of the Number of teachers in Indonesia in 2001 to that in 2007?
Your response must be concise. 0.72. What is the ratio of the Number of teachers in Italy in 2001 to that in 2007?
Give a very brief answer. 0.98. What is the ratio of the Number of teachers of Lao PDR in 2001 to that in 2007?
Offer a very short reply. 0.74. What is the ratio of the Number of teachers of Guatemala in 2002 to that in 2004?
Keep it short and to the point. 0.98. What is the ratio of the Number of teachers of Italy in 2002 to that in 2004?
Your response must be concise. 1.06. What is the ratio of the Number of teachers of Lao PDR in 2002 to that in 2004?
Give a very brief answer. 0.93. What is the ratio of the Number of teachers of Guatemala in 2002 to that in 2005?
Provide a short and direct response. 0.93. What is the ratio of the Number of teachers of Indonesia in 2002 to that in 2005?
Your answer should be compact. 0.87. What is the ratio of the Number of teachers of Italy in 2002 to that in 2005?
Your answer should be very brief. 1.03. What is the ratio of the Number of teachers of Lao PDR in 2002 to that in 2005?
Offer a terse response. 0.84. What is the ratio of the Number of teachers of Guatemala in 2002 to that in 2006?
Offer a terse response. 0.89. What is the ratio of the Number of teachers in Indonesia in 2002 to that in 2006?
Offer a very short reply. 0.81. What is the ratio of the Number of teachers of Italy in 2002 to that in 2006?
Offer a terse response. 1.03. What is the ratio of the Number of teachers in Lao PDR in 2002 to that in 2006?
Ensure brevity in your answer.  0.83. What is the ratio of the Number of teachers in Guatemala in 2002 to that in 2007?
Your answer should be very brief. 0.83. What is the ratio of the Number of teachers of Indonesia in 2002 to that in 2007?
Offer a terse response. 0.78. What is the ratio of the Number of teachers in Italy in 2002 to that in 2007?
Your response must be concise. 0.98. What is the ratio of the Number of teachers of Lao PDR in 2002 to that in 2007?
Your answer should be very brief. 0.78. What is the ratio of the Number of teachers of Guatemala in 2004 to that in 2005?
Provide a short and direct response. 0.95. What is the ratio of the Number of teachers of Indonesia in 2004 to that in 2005?
Provide a short and direct response. 0.9. What is the ratio of the Number of teachers in Italy in 2004 to that in 2005?
Your answer should be compact. 0.98. What is the ratio of the Number of teachers in Lao PDR in 2004 to that in 2005?
Offer a very short reply. 0.9. What is the ratio of the Number of teachers in Guatemala in 2004 to that in 2006?
Ensure brevity in your answer.  0.91. What is the ratio of the Number of teachers of Indonesia in 2004 to that in 2006?
Offer a terse response. 0.84. What is the ratio of the Number of teachers in Lao PDR in 2004 to that in 2006?
Your answer should be compact. 0.89. What is the ratio of the Number of teachers of Guatemala in 2004 to that in 2007?
Provide a short and direct response. 0.85. What is the ratio of the Number of teachers in Indonesia in 2004 to that in 2007?
Your answer should be compact. 0.8. What is the ratio of the Number of teachers of Italy in 2004 to that in 2007?
Offer a very short reply. 0.93. What is the ratio of the Number of teachers in Guatemala in 2005 to that in 2006?
Your answer should be very brief. 0.96. What is the ratio of the Number of teachers in Indonesia in 2005 to that in 2006?
Ensure brevity in your answer.  0.94. What is the ratio of the Number of teachers in Guatemala in 2005 to that in 2007?
Your response must be concise. 0.89. What is the ratio of the Number of teachers in Indonesia in 2005 to that in 2007?
Keep it short and to the point. 0.89. What is the ratio of the Number of teachers in Italy in 2005 to that in 2007?
Your answer should be compact. 0.95. What is the ratio of the Number of teachers in Lao PDR in 2005 to that in 2007?
Offer a very short reply. 0.93. What is the ratio of the Number of teachers in Guatemala in 2006 to that in 2007?
Provide a short and direct response. 0.93. What is the ratio of the Number of teachers in Indonesia in 2006 to that in 2007?
Your response must be concise. 0.95. What is the ratio of the Number of teachers of Italy in 2006 to that in 2007?
Ensure brevity in your answer.  0.95. What is the ratio of the Number of teachers of Lao PDR in 2006 to that in 2007?
Offer a terse response. 0.93. What is the difference between the highest and the second highest Number of teachers in Guatemala?
Ensure brevity in your answer.  3695. What is the difference between the highest and the second highest Number of teachers in Indonesia?
Provide a short and direct response. 6.54e+04. What is the difference between the highest and the second highest Number of teachers of Italy?
Your answer should be compact. 9589. What is the difference between the highest and the second highest Number of teachers of Lao PDR?
Give a very brief answer. 1123. What is the difference between the highest and the lowest Number of teachers in Guatemala?
Your answer should be compact. 1.77e+04. What is the difference between the highest and the lowest Number of teachers of Indonesia?
Provide a short and direct response. 4.25e+05. What is the difference between the highest and the lowest Number of teachers in Italy?
Give a very brief answer. 3.37e+04. What is the difference between the highest and the lowest Number of teachers in Lao PDR?
Make the answer very short. 4708. 